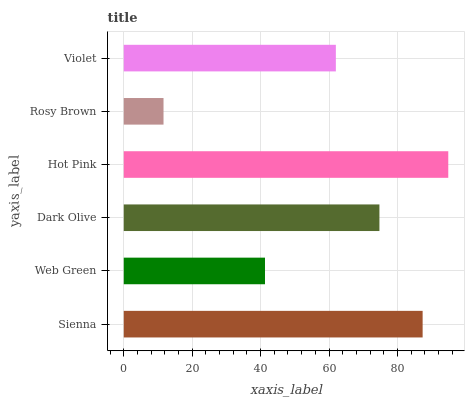Is Rosy Brown the minimum?
Answer yes or no. Yes. Is Hot Pink the maximum?
Answer yes or no. Yes. Is Web Green the minimum?
Answer yes or no. No. Is Web Green the maximum?
Answer yes or no. No. Is Sienna greater than Web Green?
Answer yes or no. Yes. Is Web Green less than Sienna?
Answer yes or no. Yes. Is Web Green greater than Sienna?
Answer yes or no. No. Is Sienna less than Web Green?
Answer yes or no. No. Is Dark Olive the high median?
Answer yes or no. Yes. Is Violet the low median?
Answer yes or no. Yes. Is Rosy Brown the high median?
Answer yes or no. No. Is Sienna the low median?
Answer yes or no. No. 